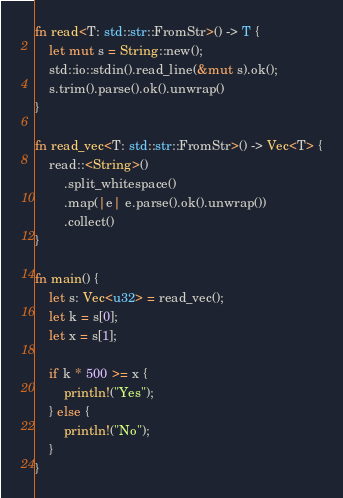<code> <loc_0><loc_0><loc_500><loc_500><_Rust_>fn read<T: std::str::FromStr>() -> T {
    let mut s = String::new();
    std::io::stdin().read_line(&mut s).ok();
    s.trim().parse().ok().unwrap()
}

fn read_vec<T: std::str::FromStr>() -> Vec<T> {
    read::<String>()
        .split_whitespace()
        .map(|e| e.parse().ok().unwrap())
        .collect()
}

fn main() {
    let s: Vec<u32> = read_vec();
    let k = s[0];
    let x = s[1];

    if k * 500 >= x {
        println!("Yes");
    } else {
        println!("No");
    }
}
</code> 